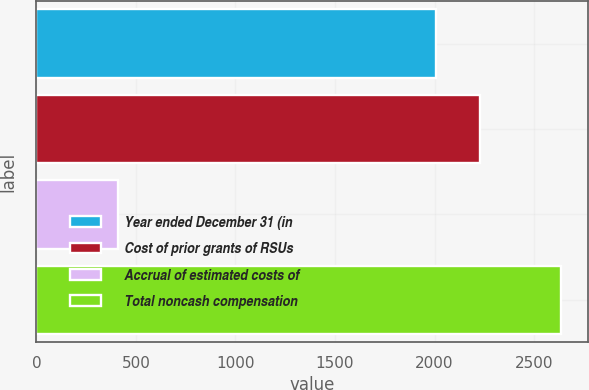Convert chart to OTSL. <chart><loc_0><loc_0><loc_500><loc_500><bar_chart><fcel>Year ended December 31 (in<fcel>Cost of prior grants of RSUs<fcel>Accrual of estimated costs of<fcel>Total noncash compensation<nl><fcel>2008<fcel>2230.8<fcel>409<fcel>2637<nl></chart> 